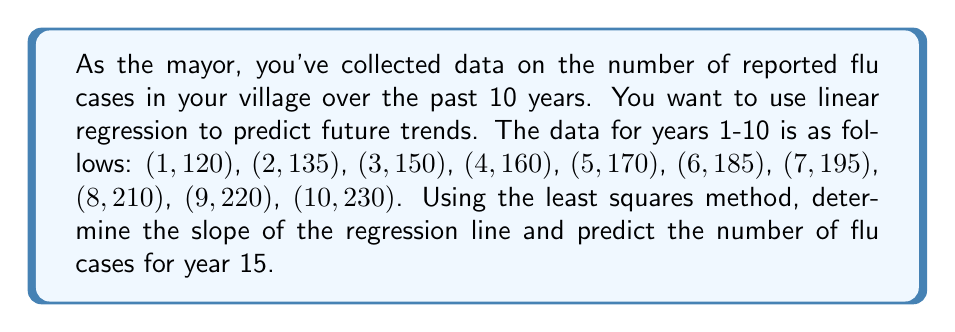Could you help me with this problem? To solve this problem, we'll use the least squares method for linear regression.

Step 1: Calculate the means of x (years) and y (flu cases).
$\bar{x} = \frac{1+2+3+4+5+6+7+8+9+10}{10} = 5.5$
$\bar{y} = \frac{120+135+150+160+170+185+195+210+220+230}{10} = 177.5$

Step 2: Calculate the slope (m) using the formula:
$$m = \frac{\sum(x_i - \bar{x})(y_i - \bar{y})}{\sum(x_i - \bar{x})^2}$$

Step 3: Calculate the numerator and denominator:
Numerator: $(1-5.5)(120-177.5) + (2-5.5)(135-177.5) + ... + (10-5.5)(230-177.5) = 1650$
Denominator: $(1-5.5)^2 + (2-5.5)^2 + ... + (10-5.5)^2 = 82.5$

Step 4: Calculate the slope:
$$m = \frac{1650}{82.5} = 20$$

Step 5: Calculate the y-intercept (b) using the formula:
$$b = \bar{y} - m\bar{x} = 177.5 - 20(5.5) = 67.5$$

Step 6: The regression line equation is:
$$y = 20x + 67.5$$

Step 7: Predict the number of flu cases for year 15:
$$y = 20(15) + 67.5 = 367.5$$

Therefore, the predicted number of flu cases for year 15 is 368 (rounded to the nearest whole number).
Answer: Slope: 20; Predicted flu cases for year 15: 368 